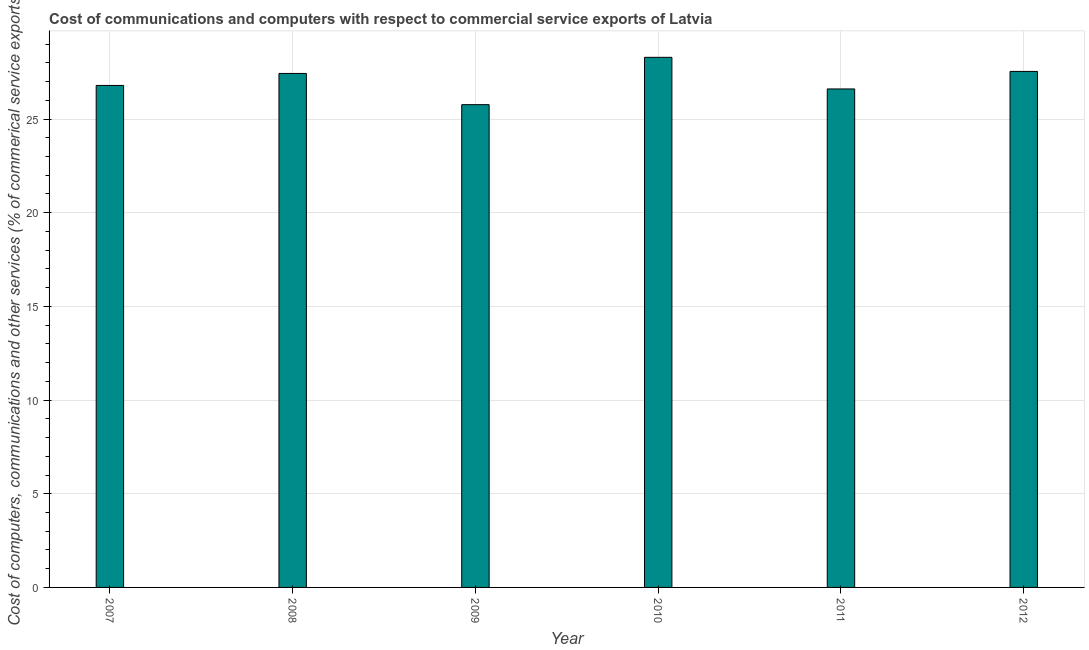What is the title of the graph?
Provide a succinct answer. Cost of communications and computers with respect to commercial service exports of Latvia. What is the label or title of the Y-axis?
Your answer should be compact. Cost of computers, communications and other services (% of commerical service exports). What is the  computer and other services in 2011?
Make the answer very short. 26.6. Across all years, what is the maximum cost of communications?
Provide a succinct answer. 28.29. Across all years, what is the minimum  computer and other services?
Your response must be concise. 25.77. In which year was the cost of communications maximum?
Give a very brief answer. 2010. What is the sum of the  computer and other services?
Provide a short and direct response. 162.43. What is the difference between the  computer and other services in 2009 and 2011?
Your answer should be very brief. -0.84. What is the average  computer and other services per year?
Your answer should be compact. 27.07. What is the median  computer and other services?
Offer a terse response. 27.11. What is the ratio of the cost of communications in 2007 to that in 2011?
Your answer should be very brief. 1.01. Is the difference between the cost of communications in 2008 and 2009 greater than the difference between any two years?
Your response must be concise. No. What is the difference between the highest and the second highest cost of communications?
Ensure brevity in your answer.  0.75. Is the sum of the  computer and other services in 2009 and 2012 greater than the maximum  computer and other services across all years?
Keep it short and to the point. Yes. What is the difference between the highest and the lowest  computer and other services?
Give a very brief answer. 2.53. Are all the bars in the graph horizontal?
Your answer should be compact. No. How many years are there in the graph?
Keep it short and to the point. 6. What is the difference between two consecutive major ticks on the Y-axis?
Give a very brief answer. 5. Are the values on the major ticks of Y-axis written in scientific E-notation?
Your response must be concise. No. What is the Cost of computers, communications and other services (% of commerical service exports) of 2007?
Offer a very short reply. 26.79. What is the Cost of computers, communications and other services (% of commerical service exports) in 2008?
Your answer should be compact. 27.43. What is the Cost of computers, communications and other services (% of commerical service exports) of 2009?
Provide a short and direct response. 25.77. What is the Cost of computers, communications and other services (% of commerical service exports) in 2010?
Give a very brief answer. 28.29. What is the Cost of computers, communications and other services (% of commerical service exports) in 2011?
Ensure brevity in your answer.  26.6. What is the Cost of computers, communications and other services (% of commerical service exports) in 2012?
Keep it short and to the point. 27.54. What is the difference between the Cost of computers, communications and other services (% of commerical service exports) in 2007 and 2008?
Provide a short and direct response. -0.64. What is the difference between the Cost of computers, communications and other services (% of commerical service exports) in 2007 and 2009?
Provide a short and direct response. 1.03. What is the difference between the Cost of computers, communications and other services (% of commerical service exports) in 2007 and 2010?
Give a very brief answer. -1.5. What is the difference between the Cost of computers, communications and other services (% of commerical service exports) in 2007 and 2011?
Make the answer very short. 0.19. What is the difference between the Cost of computers, communications and other services (% of commerical service exports) in 2007 and 2012?
Give a very brief answer. -0.75. What is the difference between the Cost of computers, communications and other services (% of commerical service exports) in 2008 and 2009?
Offer a terse response. 1.67. What is the difference between the Cost of computers, communications and other services (% of commerical service exports) in 2008 and 2010?
Your answer should be very brief. -0.86. What is the difference between the Cost of computers, communications and other services (% of commerical service exports) in 2008 and 2011?
Provide a short and direct response. 0.83. What is the difference between the Cost of computers, communications and other services (% of commerical service exports) in 2008 and 2012?
Offer a terse response. -0.11. What is the difference between the Cost of computers, communications and other services (% of commerical service exports) in 2009 and 2010?
Your answer should be compact. -2.53. What is the difference between the Cost of computers, communications and other services (% of commerical service exports) in 2009 and 2011?
Your answer should be compact. -0.84. What is the difference between the Cost of computers, communications and other services (% of commerical service exports) in 2009 and 2012?
Your answer should be very brief. -1.77. What is the difference between the Cost of computers, communications and other services (% of commerical service exports) in 2010 and 2011?
Give a very brief answer. 1.69. What is the difference between the Cost of computers, communications and other services (% of commerical service exports) in 2010 and 2012?
Make the answer very short. 0.75. What is the difference between the Cost of computers, communications and other services (% of commerical service exports) in 2011 and 2012?
Offer a very short reply. -0.94. What is the ratio of the Cost of computers, communications and other services (% of commerical service exports) in 2007 to that in 2010?
Offer a very short reply. 0.95. What is the ratio of the Cost of computers, communications and other services (% of commerical service exports) in 2007 to that in 2012?
Ensure brevity in your answer.  0.97. What is the ratio of the Cost of computers, communications and other services (% of commerical service exports) in 2008 to that in 2009?
Provide a short and direct response. 1.06. What is the ratio of the Cost of computers, communications and other services (% of commerical service exports) in 2008 to that in 2010?
Give a very brief answer. 0.97. What is the ratio of the Cost of computers, communications and other services (% of commerical service exports) in 2008 to that in 2011?
Provide a short and direct response. 1.03. What is the ratio of the Cost of computers, communications and other services (% of commerical service exports) in 2009 to that in 2010?
Make the answer very short. 0.91. What is the ratio of the Cost of computers, communications and other services (% of commerical service exports) in 2009 to that in 2012?
Provide a short and direct response. 0.94. What is the ratio of the Cost of computers, communications and other services (% of commerical service exports) in 2010 to that in 2011?
Your response must be concise. 1.06. 